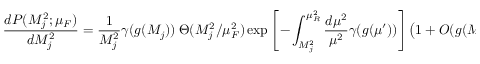Convert formula to latex. <formula><loc_0><loc_0><loc_500><loc_500>\frac { d P ( M _ { j } ^ { 2 } ; \mu _ { F } ) } { d M _ { j } ^ { 2 } } = \frac { 1 } { M _ { j } ^ { 2 } } \gamma ( g ( M _ { j } ) ) \Theta ( M _ { j } ^ { 2 } / \mu _ { F } ^ { 2 } ) \exp \left [ - \int _ { M _ { j } ^ { 2 } } ^ { \mu _ { R } ^ { 2 } } \frac { d \mu ^ { 2 } } { \mu ^ { 2 } } \gamma ( g ( \mu ^ { \prime } ) ) \right ] \left ( 1 + O ( g ( M _ { j } ) ^ { 2 } ) \right ) .</formula> 